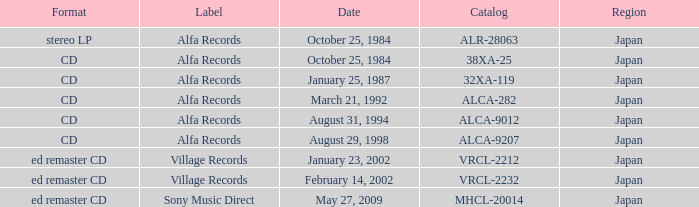What was the region of the release from May 27, 2009? Japan. 